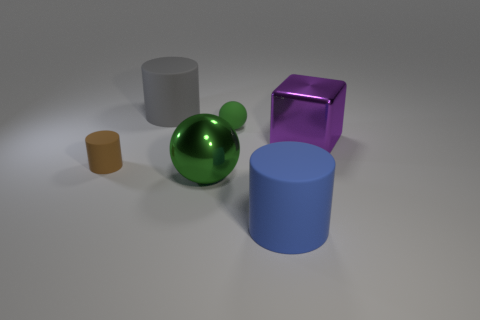Add 4 big green metal things. How many objects exist? 10 Subtract all blocks. How many objects are left? 5 Add 6 big green shiny objects. How many big green shiny objects exist? 7 Subtract 0 yellow cylinders. How many objects are left? 6 Subtract all brown rubber cylinders. Subtract all tiny spheres. How many objects are left? 4 Add 3 large green metal spheres. How many large green metal spheres are left? 4 